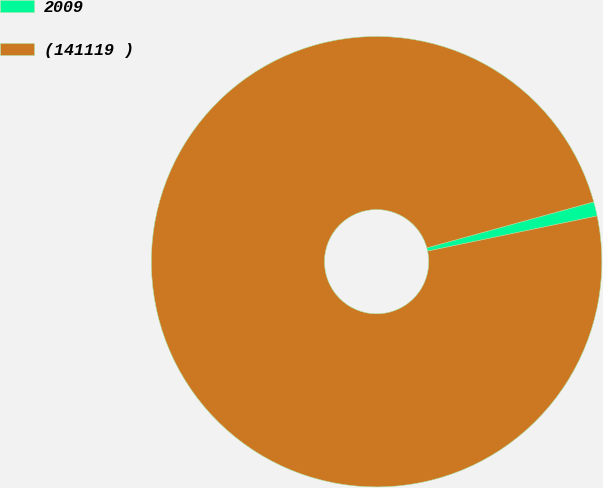Convert chart. <chart><loc_0><loc_0><loc_500><loc_500><pie_chart><fcel>2009<fcel>(141119 )<nl><fcel>1.02%<fcel>98.98%<nl></chart> 